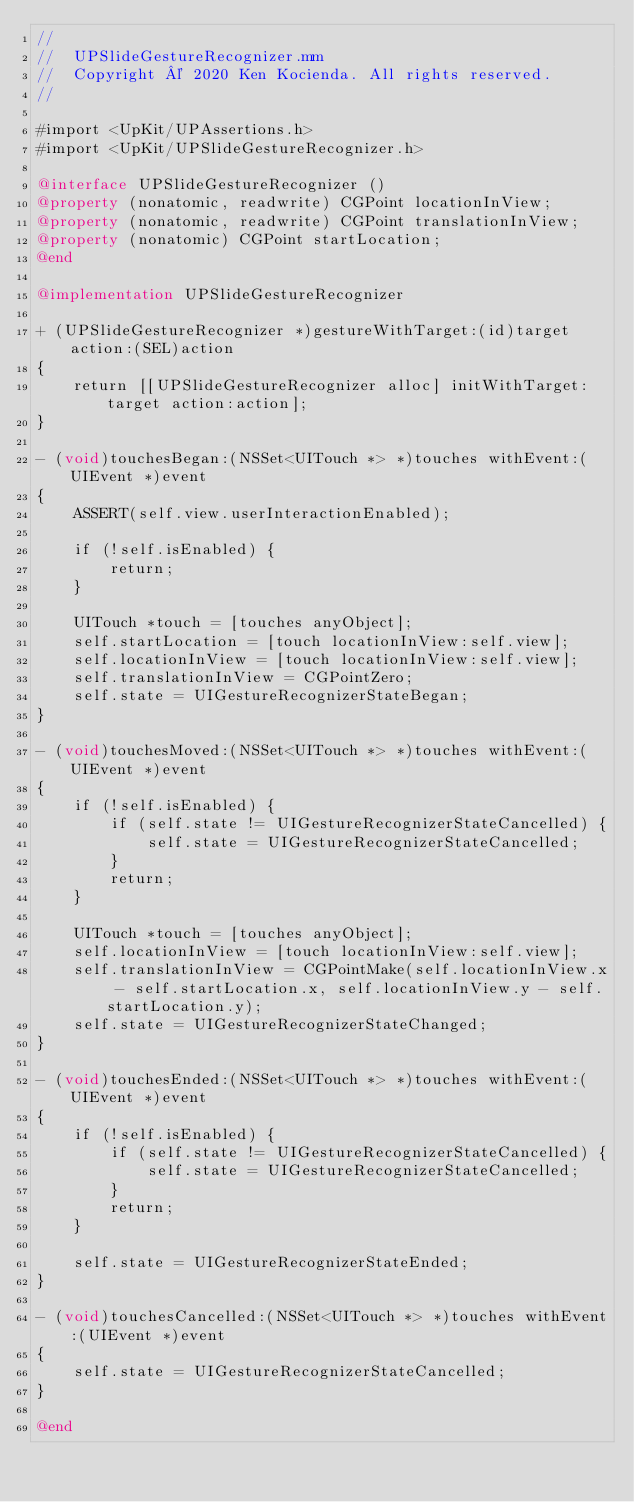<code> <loc_0><loc_0><loc_500><loc_500><_ObjectiveC_>//
//  UPSlideGestureRecognizer.mm
//  Copyright © 2020 Ken Kocienda. All rights reserved.
//

#import <UpKit/UPAssertions.h>
#import <UpKit/UPSlideGestureRecognizer.h>

@interface UPSlideGestureRecognizer ()
@property (nonatomic, readwrite) CGPoint locationInView;
@property (nonatomic, readwrite) CGPoint translationInView;
@property (nonatomic) CGPoint startLocation;
@end

@implementation UPSlideGestureRecognizer

+ (UPSlideGestureRecognizer *)gestureWithTarget:(id)target action:(SEL)action
{
    return [[UPSlideGestureRecognizer alloc] initWithTarget:target action:action];
}

- (void)touchesBegan:(NSSet<UITouch *> *)touches withEvent:(UIEvent *)event
{
    ASSERT(self.view.userInteractionEnabled);
    
    if (!self.isEnabled) {
        return;
    }
    
    UITouch *touch = [touches anyObject];
    self.startLocation = [touch locationInView:self.view];
    self.locationInView = [touch locationInView:self.view];
    self.translationInView = CGPointZero;
    self.state = UIGestureRecognizerStateBegan;
}

- (void)touchesMoved:(NSSet<UITouch *> *)touches withEvent:(UIEvent *)event
{
    if (!self.isEnabled) {
        if (self.state != UIGestureRecognizerStateCancelled) {
            self.state = UIGestureRecognizerStateCancelled;
        }
        return;
    }

    UITouch *touch = [touches anyObject];
    self.locationInView = [touch locationInView:self.view];
    self.translationInView = CGPointMake(self.locationInView.x - self.startLocation.x, self.locationInView.y - self.startLocation.y);
    self.state = UIGestureRecognizerStateChanged;
}

- (void)touchesEnded:(NSSet<UITouch *> *)touches withEvent:(UIEvent *)event
{
    if (!self.isEnabled) {
        if (self.state != UIGestureRecognizerStateCancelled) {
            self.state = UIGestureRecognizerStateCancelled;
        }
        return;
    }

    self.state = UIGestureRecognizerStateEnded;
}

- (void)touchesCancelled:(NSSet<UITouch *> *)touches withEvent:(UIEvent *)event
{
    self.state = UIGestureRecognizerStateCancelled;
}

@end
</code> 